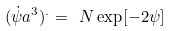<formula> <loc_0><loc_0><loc_500><loc_500>( \dot { \psi } a ^ { 3 } ) ^ { . } = \ N \exp [ - 2 \psi ]</formula> 